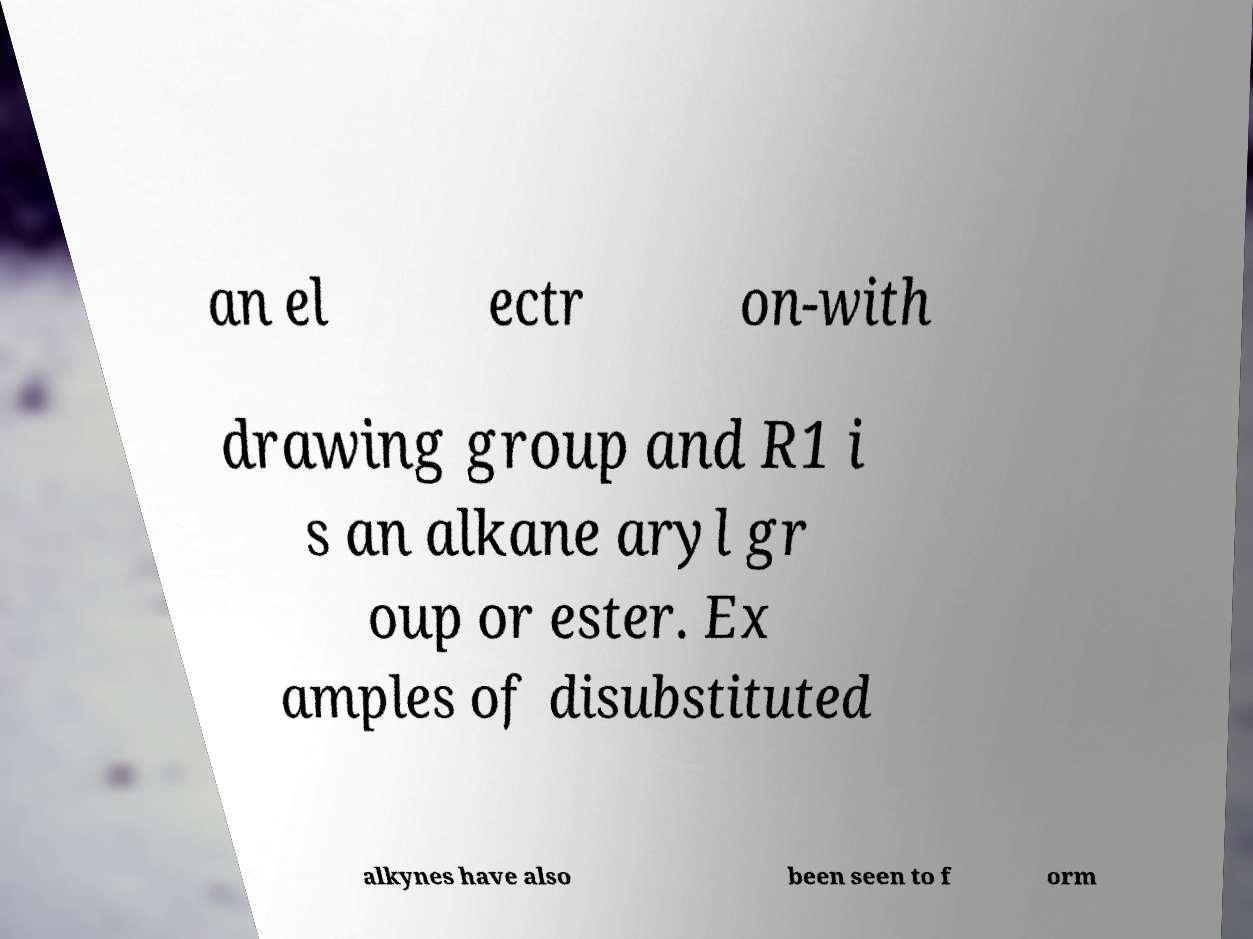Please read and relay the text visible in this image. What does it say? an el ectr on-with drawing group and R1 i s an alkane aryl gr oup or ester. Ex amples of disubstituted alkynes have also been seen to f orm 